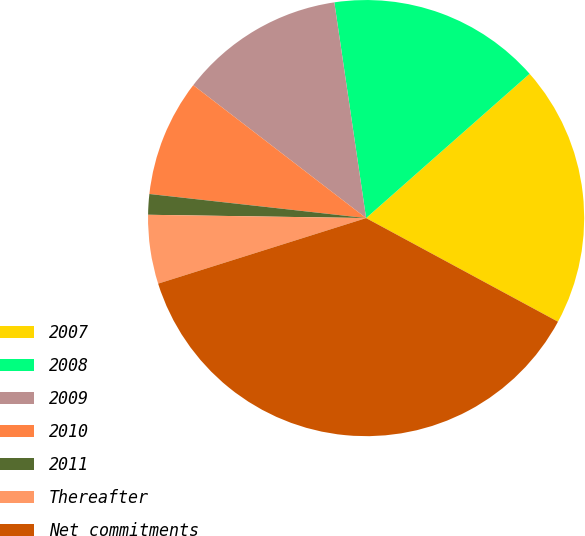Convert chart to OTSL. <chart><loc_0><loc_0><loc_500><loc_500><pie_chart><fcel>2007<fcel>2008<fcel>2009<fcel>2010<fcel>2011<fcel>Thereafter<fcel>Net commitments<nl><fcel>19.39%<fcel>15.82%<fcel>12.24%<fcel>8.67%<fcel>1.52%<fcel>5.1%<fcel>37.26%<nl></chart> 